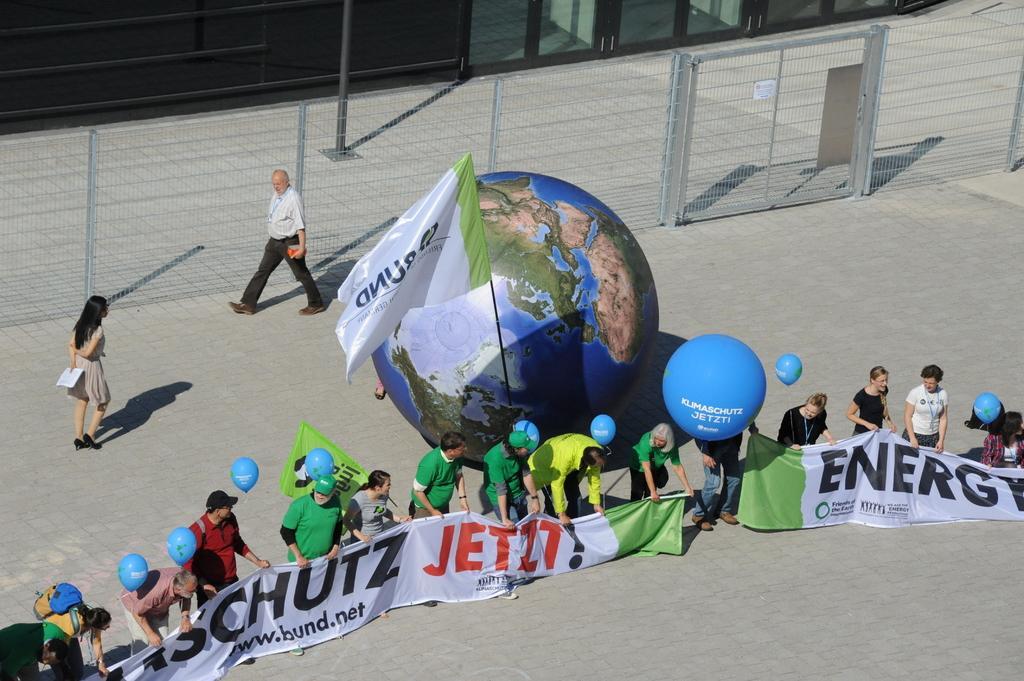Please provide a concise description of this image. This image is taken outdoors. At the bottom of the image there is a floor. In the background there is a fence. There are a few iron bars and a pole. In the middle of the image many people are standing on the floor and they are holding banners with a text on them and there are a few balloons. There is an artificial globe and a flag. A man is walking on the floor and a woman is walking on the floor. 